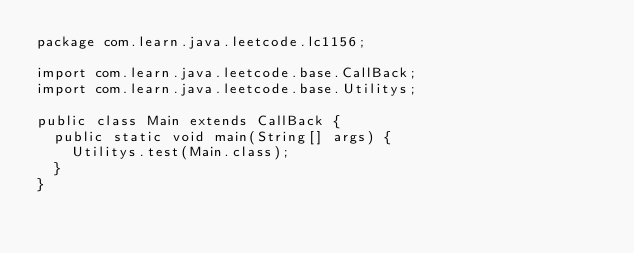<code> <loc_0><loc_0><loc_500><loc_500><_Java_>package com.learn.java.leetcode.lc1156;

import com.learn.java.leetcode.base.CallBack;
import com.learn.java.leetcode.base.Utilitys;

public class Main extends CallBack {
	public static void main(String[] args) {
		Utilitys.test(Main.class);
	}
}
</code> 